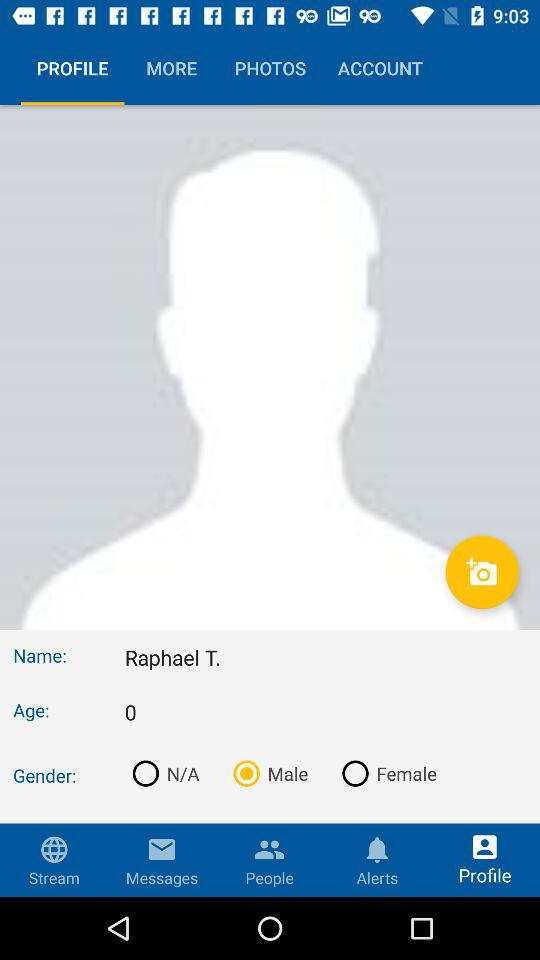What is the age? The age is 0. 